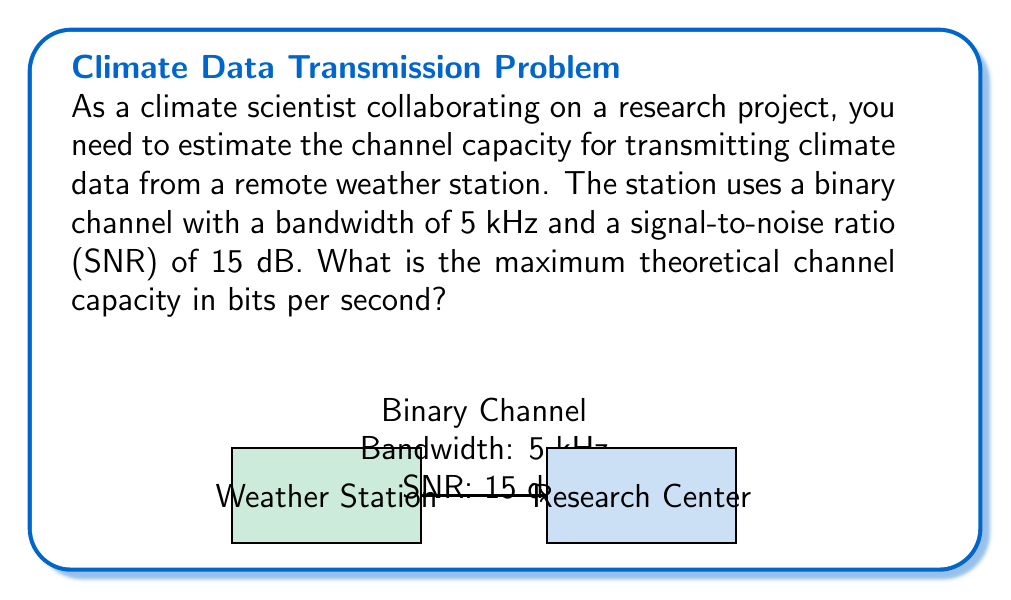Show me your answer to this math problem. To estimate the channel capacity for transmitting climate data, we can use the Shannon-Hartley theorem. This theorem provides the maximum rate at which information can be transmitted over a communications channel of a specified bandwidth in the presence of noise.

The Shannon-Hartley theorem is given by:

$$ C = B \log_2(1 + SNR) $$

Where:
- $C$ is the channel capacity in bits per second (bps)
- $B$ is the bandwidth of the channel in Hz
- $SNR$ is the signal-to-noise ratio

Given:
- Bandwidth ($B$) = 5 kHz = 5,000 Hz
- SNR = 15 dB

Step 1: Convert SNR from dB to a linear scale
$SNR_{linear} = 10^{(SNR_{dB} / 10)} = 10^{(15 / 10)} = 10^{1.5} \approx 31.6228$

Step 2: Apply the Shannon-Hartley theorem
$$ C = 5000 \log_2(1 + 31.6228) $$

Step 3: Calculate the logarithm
$\log_2(1 + 31.6228) \approx 5.0224$

Step 4: Multiply by the bandwidth
$C = 5000 \times 5.0224 \approx 25,112$ bits per second

Therefore, the maximum theoretical channel capacity is approximately 25,112 bps or 25.112 kbps.
Answer: 25,112 bps 